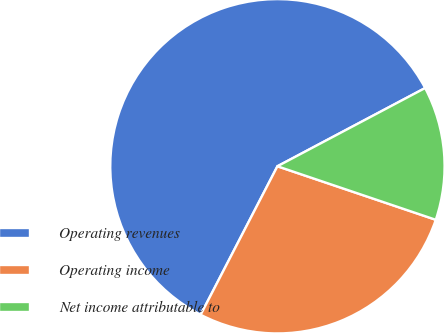Convert chart to OTSL. <chart><loc_0><loc_0><loc_500><loc_500><pie_chart><fcel>Operating revenues<fcel>Operating income<fcel>Net income attributable to<nl><fcel>59.66%<fcel>27.41%<fcel>12.94%<nl></chart> 